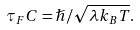Convert formula to latex. <formula><loc_0><loc_0><loc_500><loc_500>\tau _ { F } C = \hslash / \sqrt { \lambda k _ { B } T } .</formula> 